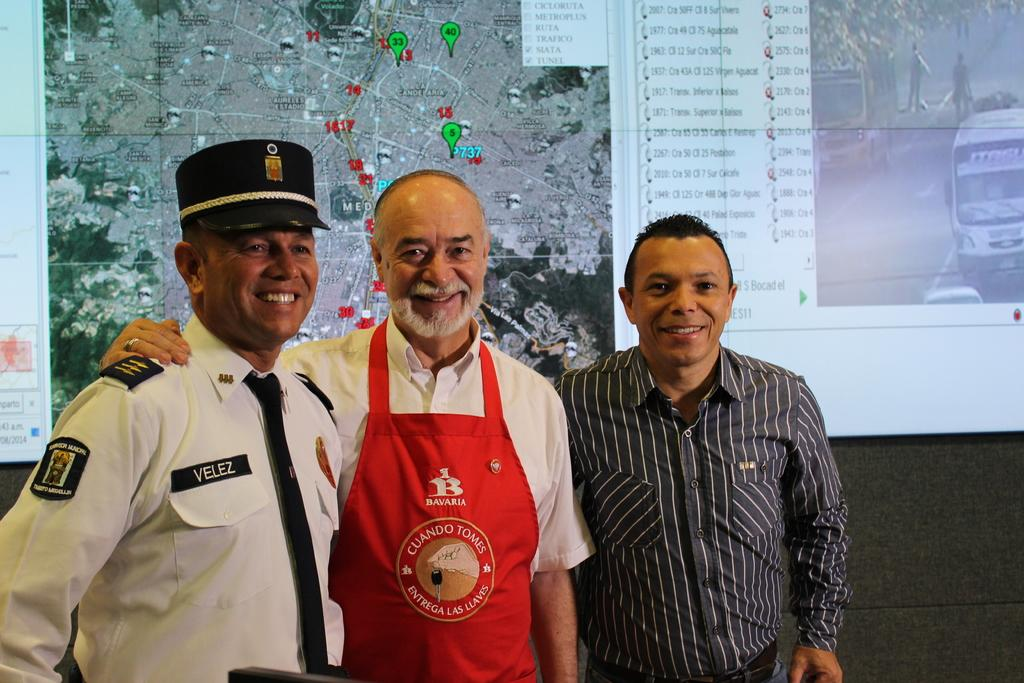<image>
Create a compact narrative representing the image presented. Three men posing for a photo with one man wearing a vest that says Cuando Tomes. 